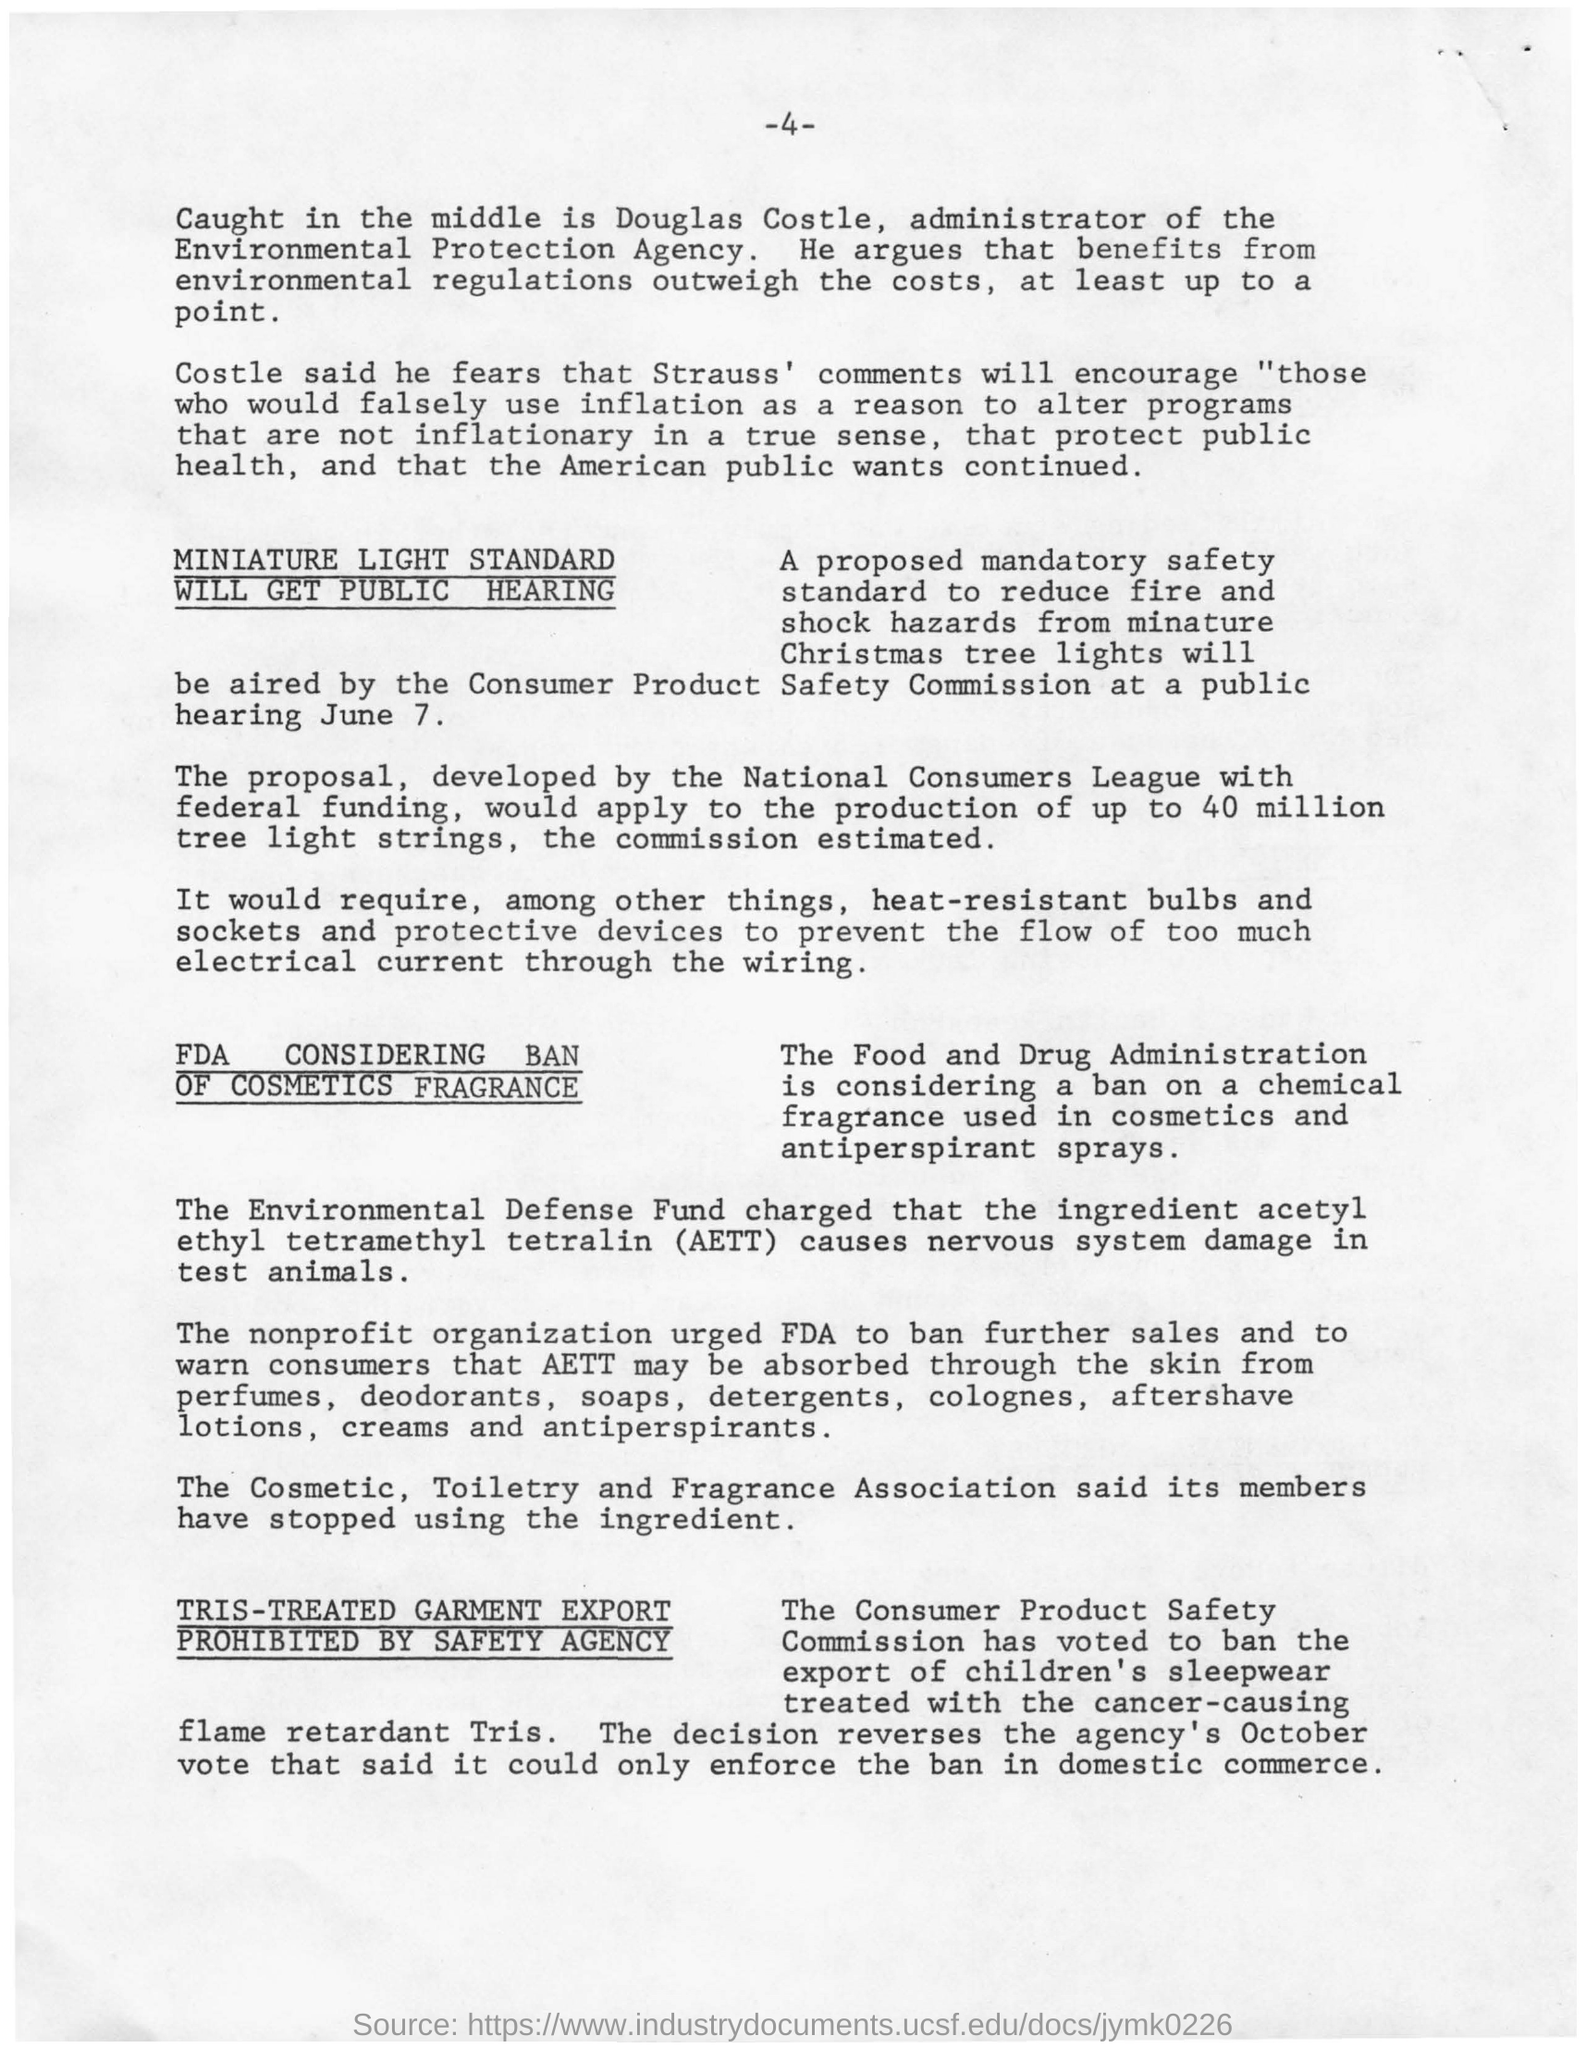What is the fullform of AETT?
Offer a very short reply. Acetyl ethyl tetramethyl tetralin. What is the page no mentioned in this document?
Keep it short and to the point. 4. 